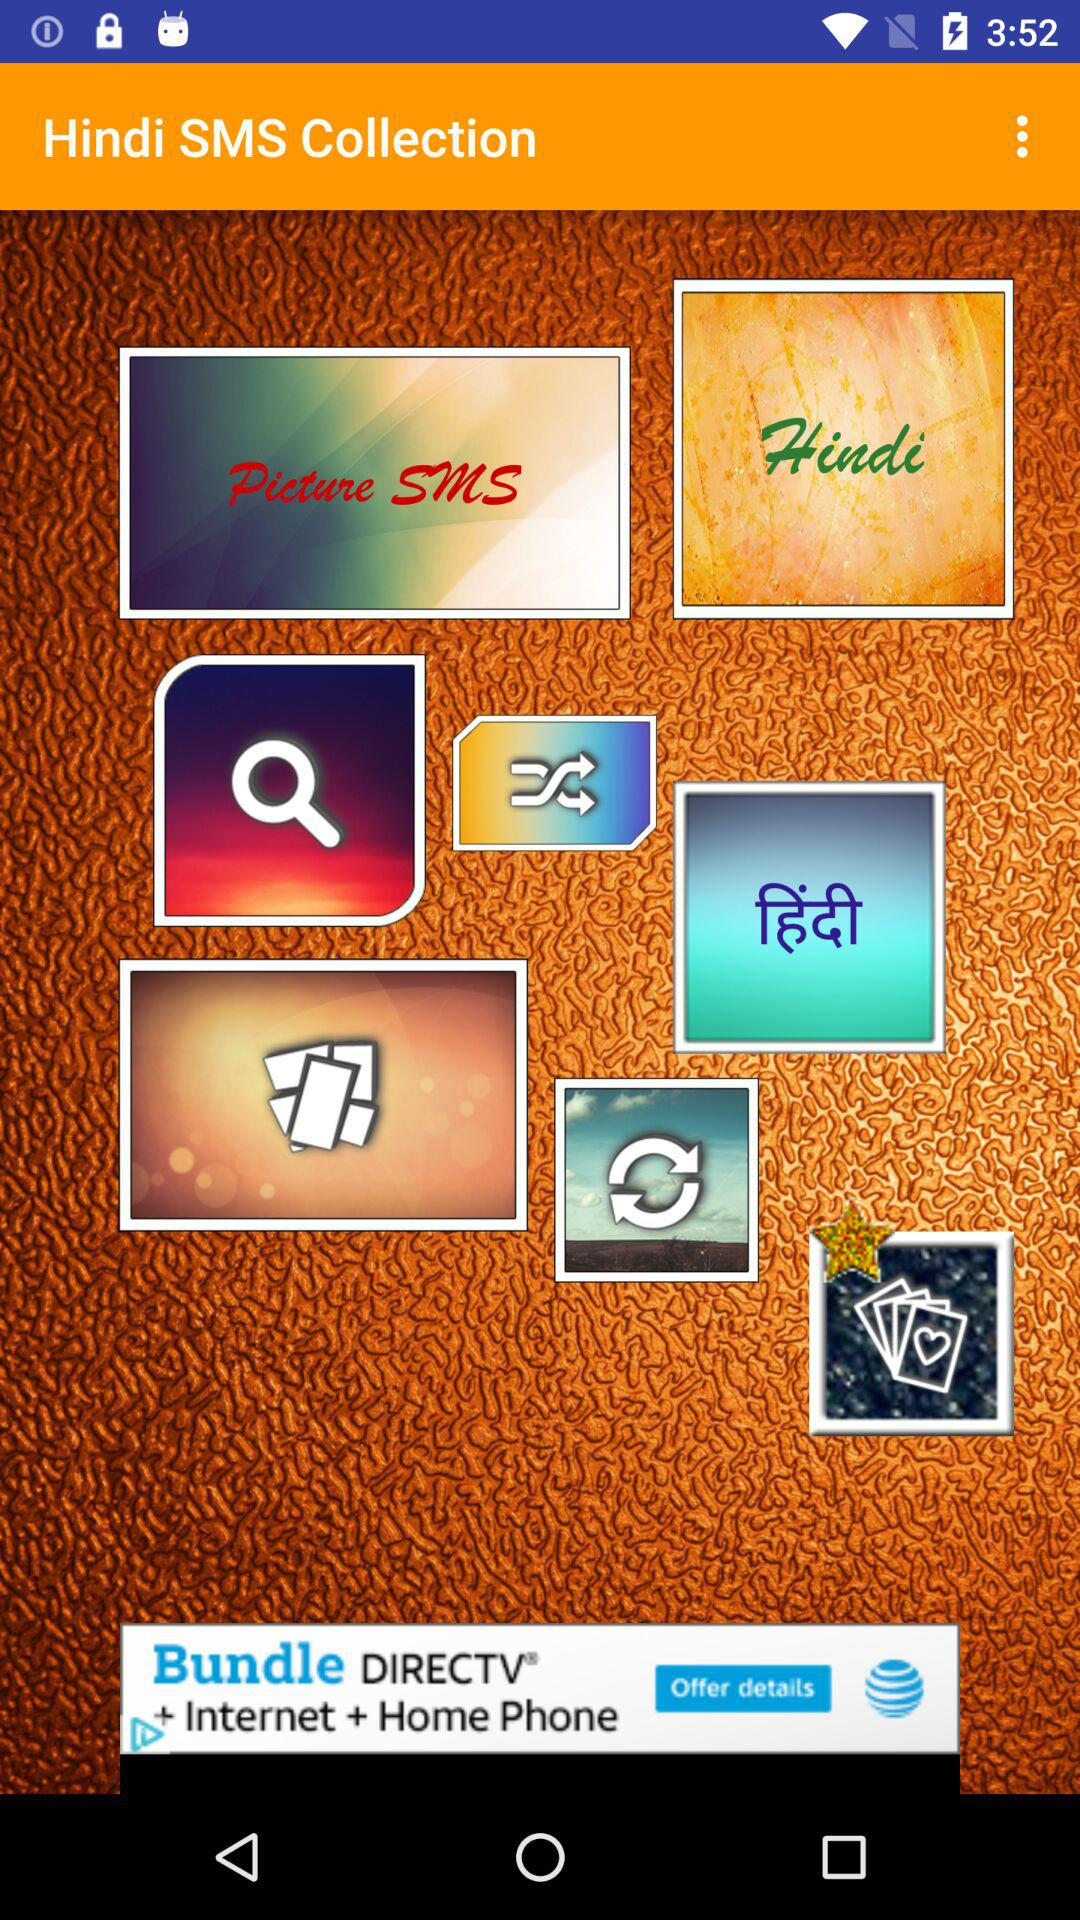What is the app name? The app name is "Hindi SMS Collection". 